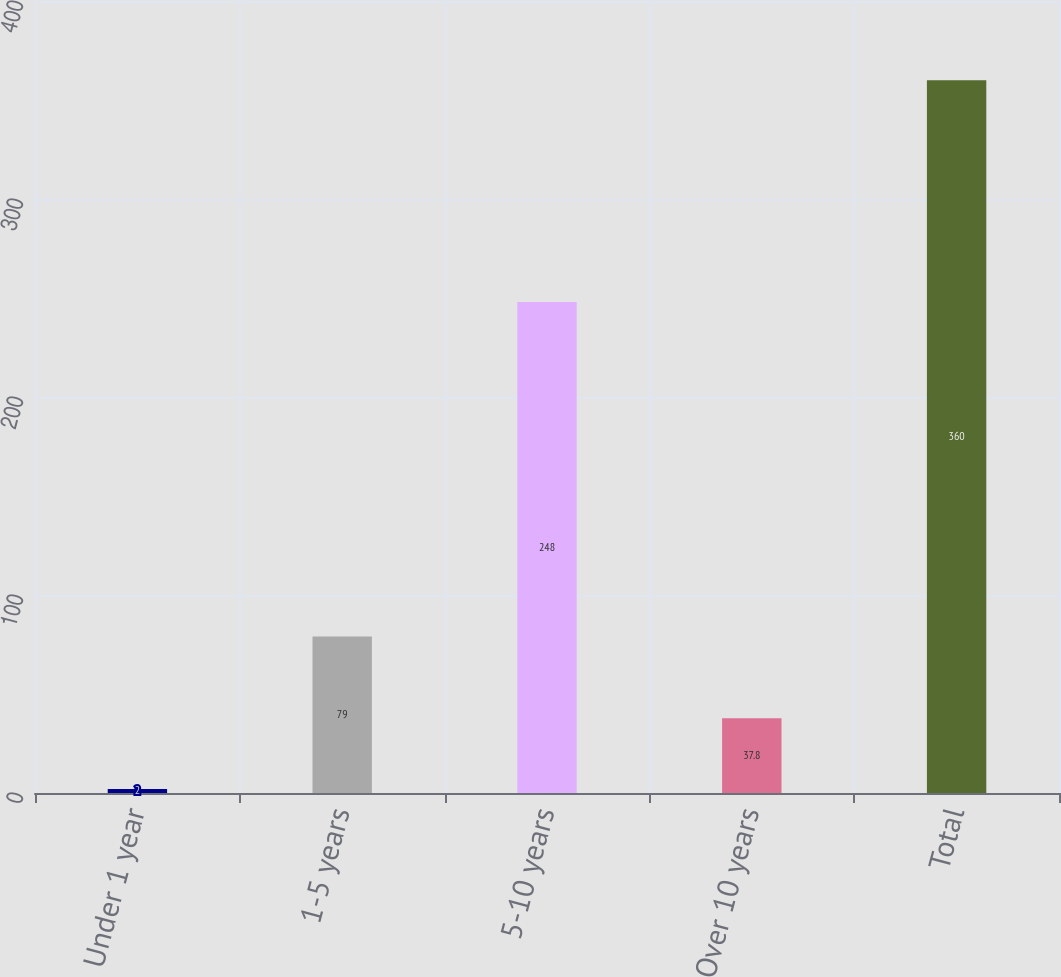Convert chart to OTSL. <chart><loc_0><loc_0><loc_500><loc_500><bar_chart><fcel>Under 1 year<fcel>1-5 years<fcel>5-10 years<fcel>Over 10 years<fcel>Total<nl><fcel>2<fcel>79<fcel>248<fcel>37.8<fcel>360<nl></chart> 